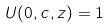Convert formula to latex. <formula><loc_0><loc_0><loc_500><loc_500>U ( 0 , c , z ) = 1</formula> 